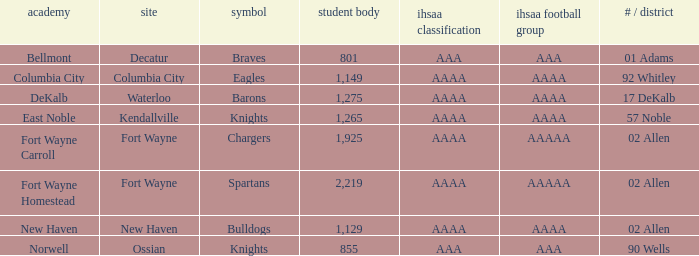What's the enrollment for Kendallville? 1265.0. 